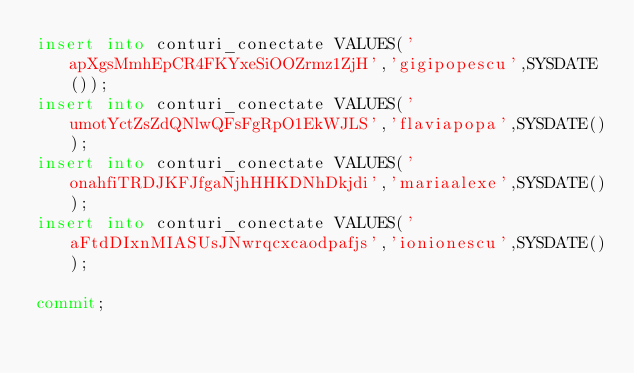<code> <loc_0><loc_0><loc_500><loc_500><_SQL_>insert into conturi_conectate VALUES('apXgsMmhEpCR4FKYxeSiOOZrmz1ZjH','gigipopescu',SYSDATE());
insert into conturi_conectate VALUES('umotYctZsZdQNlwQFsFgRpO1EkWJLS','flaviapopa',SYSDATE());
insert into conturi_conectate VALUES('onahfiTRDJKFJfgaNjhHHKDNhDkjdi','mariaalexe',SYSDATE());
insert into conturi_conectate VALUES('aFtdDIxnMIASUsJNwrqcxcaodpafjs','ionionescu',SYSDATE());

commit;</code> 